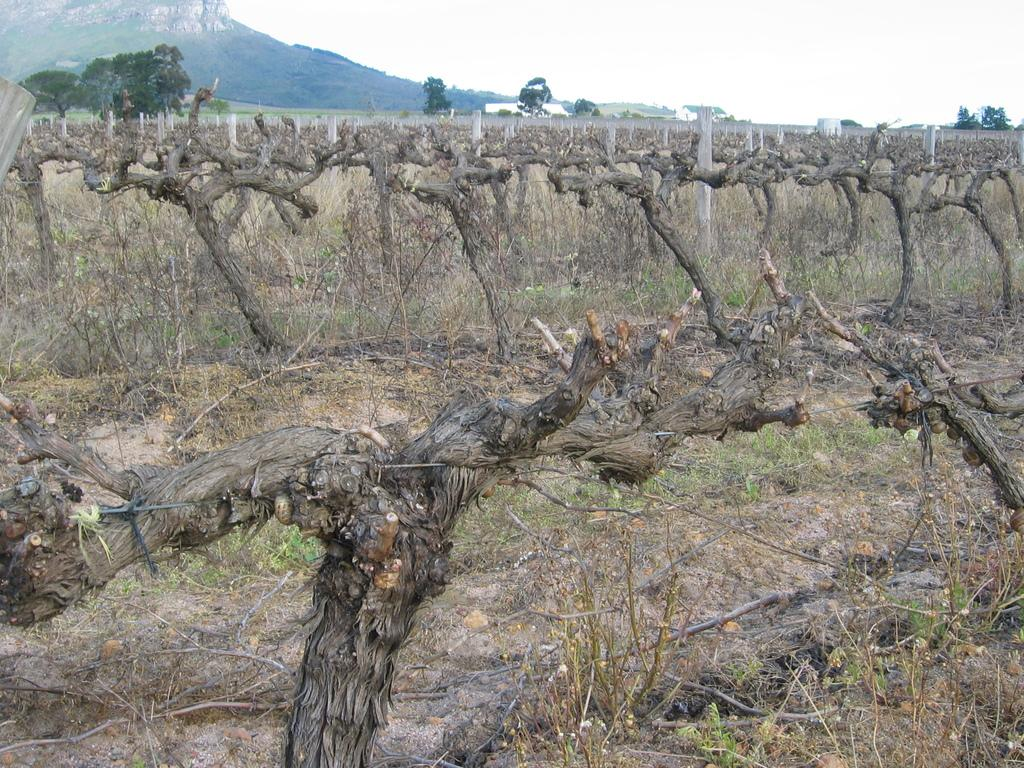What type of vegetation can be seen in the image? There are trees in the image. Can you describe the condition of some of the trees? Some trees appear to be dry in the image. What structures are present in the image? There are poles in the image. What natural landmark can be seen in the image? There is a mountain in the image. What is visible in the sky in the image? The sky is visible in the image. What objects are on the ground in the image? There are sticks on the ground in the image. What type of home can be seen in the image? There is no home present in the image. What things are being used to create a border in the image? There is no border or any objects being used to create a border in the image. 